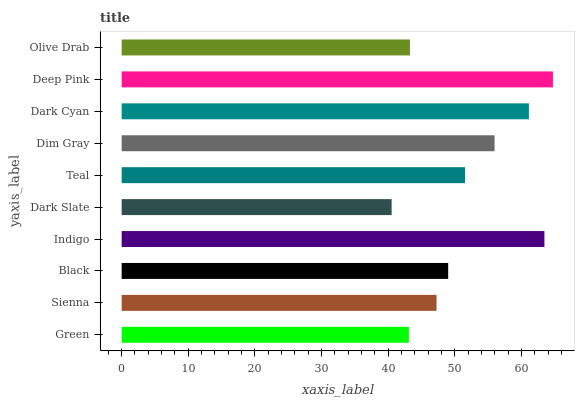Is Dark Slate the minimum?
Answer yes or no. Yes. Is Deep Pink the maximum?
Answer yes or no. Yes. Is Sienna the minimum?
Answer yes or no. No. Is Sienna the maximum?
Answer yes or no. No. Is Sienna greater than Green?
Answer yes or no. Yes. Is Green less than Sienna?
Answer yes or no. Yes. Is Green greater than Sienna?
Answer yes or no. No. Is Sienna less than Green?
Answer yes or no. No. Is Teal the high median?
Answer yes or no. Yes. Is Black the low median?
Answer yes or no. Yes. Is Dim Gray the high median?
Answer yes or no. No. Is Green the low median?
Answer yes or no. No. 